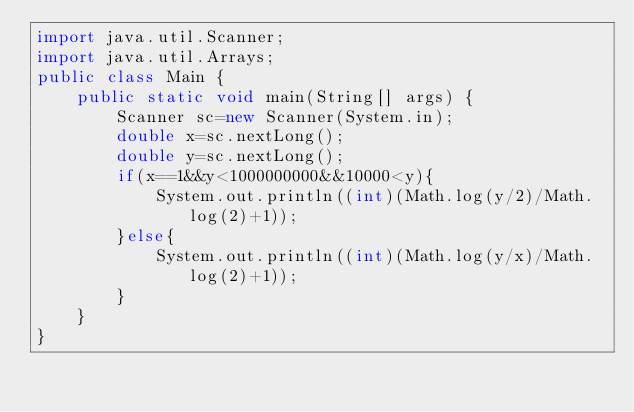<code> <loc_0><loc_0><loc_500><loc_500><_Java_>import java.util.Scanner;
import java.util.Arrays;
public class Main {
    public static void main(String[] args) {
        Scanner sc=new Scanner(System.in);
        double x=sc.nextLong();
        double y=sc.nextLong();
        if(x==1&&y<1000000000&&10000<y){
            System.out.println((int)(Math.log(y/2)/Math.log(2)+1));
        }else{
            System.out.println((int)(Math.log(y/x)/Math.log(2)+1));
        }
    }
}</code> 